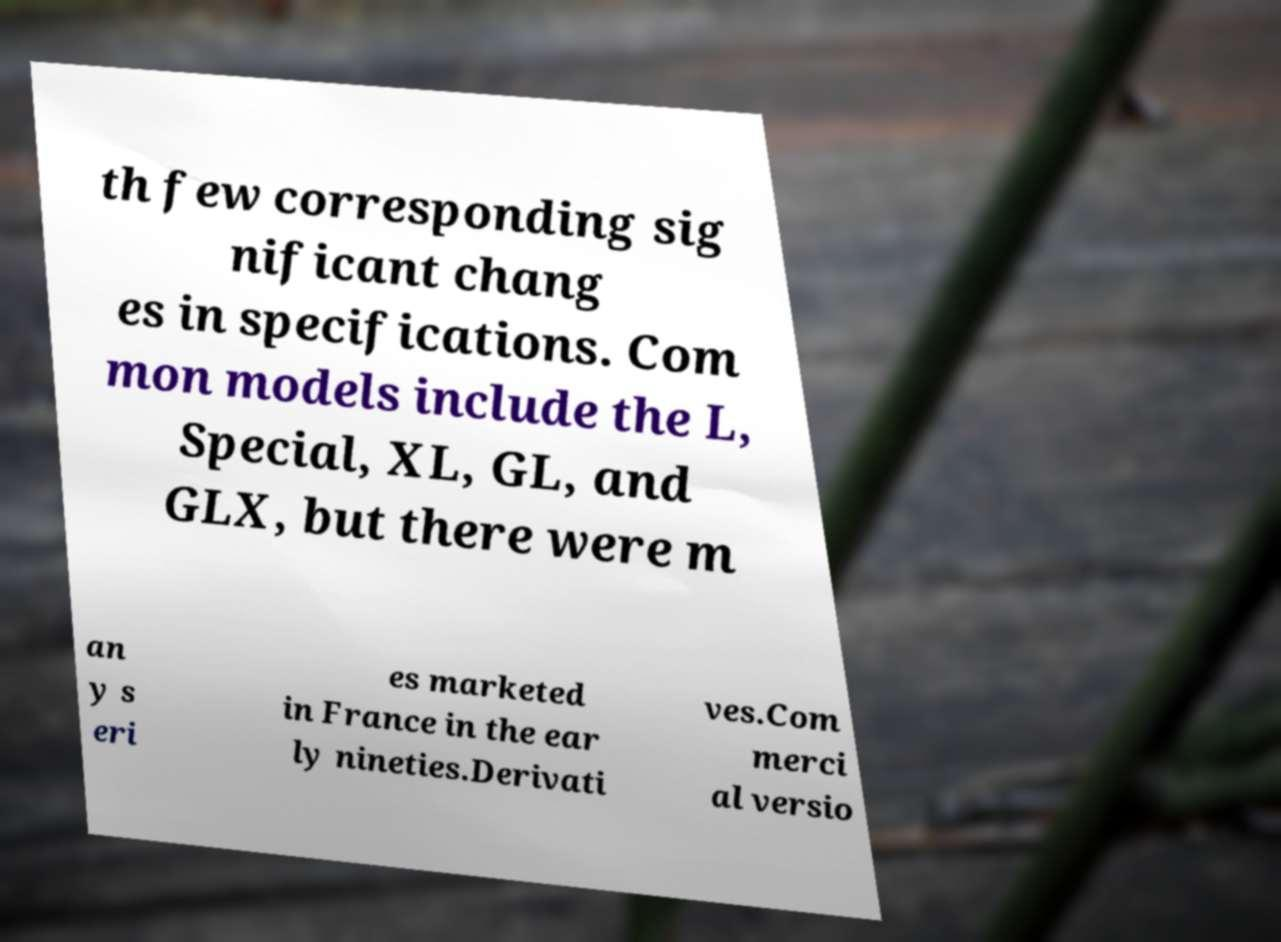Can you read and provide the text displayed in the image?This photo seems to have some interesting text. Can you extract and type it out for me? th few corresponding sig nificant chang es in specifications. Com mon models include the L, Special, XL, GL, and GLX, but there were m an y s eri es marketed in France in the ear ly nineties.Derivati ves.Com merci al versio 